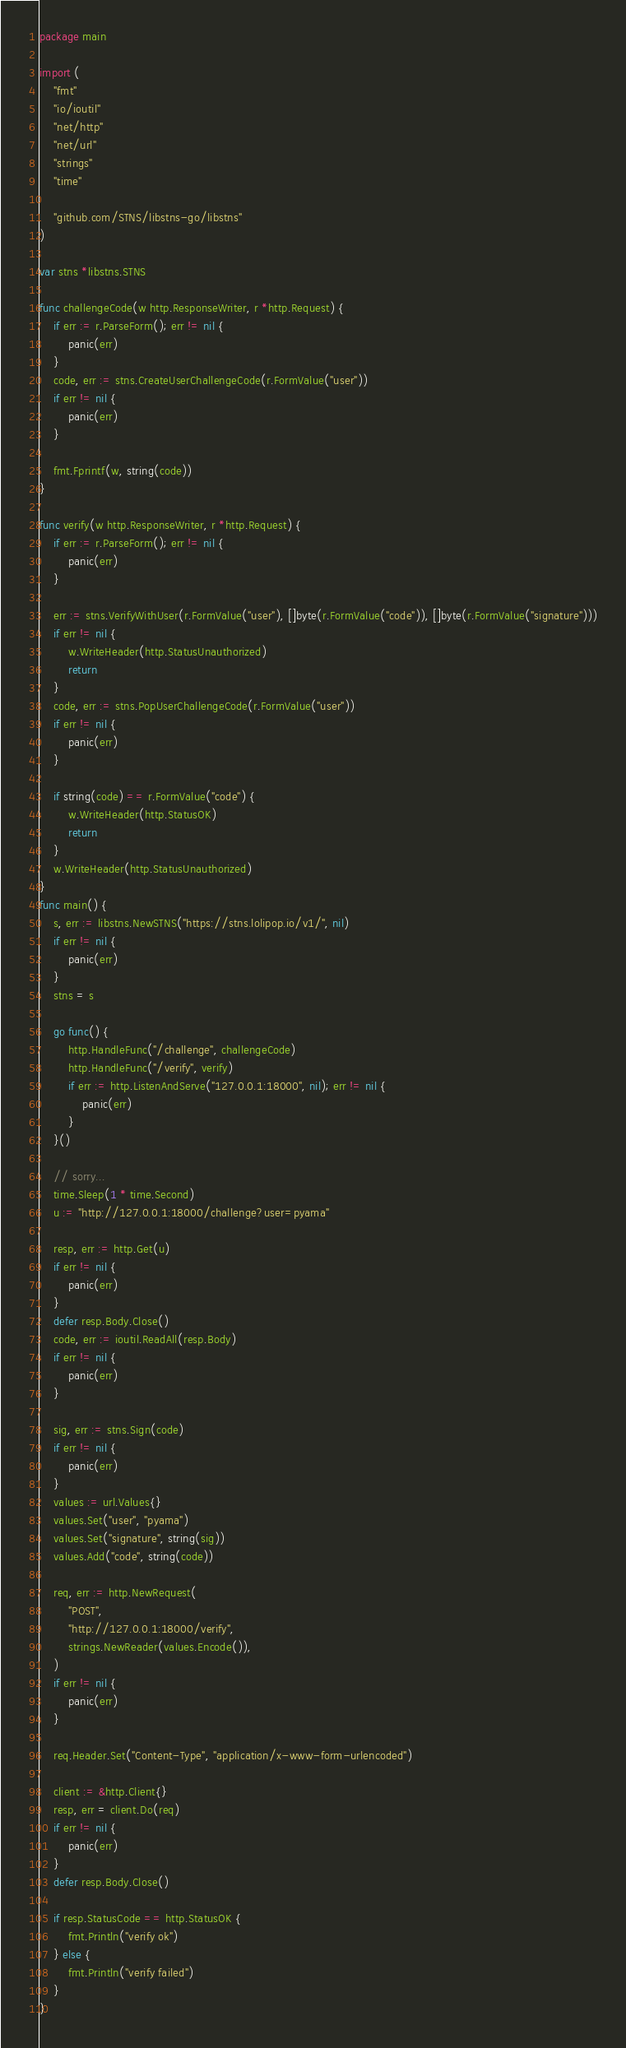Convert code to text. <code><loc_0><loc_0><loc_500><loc_500><_Go_>package main

import (
	"fmt"
	"io/ioutil"
	"net/http"
	"net/url"
	"strings"
	"time"

	"github.com/STNS/libstns-go/libstns"
)

var stns *libstns.STNS

func challengeCode(w http.ResponseWriter, r *http.Request) {
	if err := r.ParseForm(); err != nil {
		panic(err)
	}
	code, err := stns.CreateUserChallengeCode(r.FormValue("user"))
	if err != nil {
		panic(err)
	}

	fmt.Fprintf(w, string(code))
}

func verify(w http.ResponseWriter, r *http.Request) {
	if err := r.ParseForm(); err != nil {
		panic(err)
	}

	err := stns.VerifyWithUser(r.FormValue("user"), []byte(r.FormValue("code")), []byte(r.FormValue("signature")))
	if err != nil {
		w.WriteHeader(http.StatusUnauthorized)
		return
	}
	code, err := stns.PopUserChallengeCode(r.FormValue("user"))
	if err != nil {
		panic(err)
	}

	if string(code) == r.FormValue("code") {
		w.WriteHeader(http.StatusOK)
		return
	}
	w.WriteHeader(http.StatusUnauthorized)
}
func main() {
	s, err := libstns.NewSTNS("https://stns.lolipop.io/v1/", nil)
	if err != nil {
		panic(err)
	}
	stns = s

	go func() {
		http.HandleFunc("/challenge", challengeCode)
		http.HandleFunc("/verify", verify)
		if err := http.ListenAndServe("127.0.0.1:18000", nil); err != nil {
			panic(err)
		}
	}()

	// sorry...
	time.Sleep(1 * time.Second)
	u := "http://127.0.0.1:18000/challenge?user=pyama"

	resp, err := http.Get(u)
	if err != nil {
		panic(err)
	}
	defer resp.Body.Close()
	code, err := ioutil.ReadAll(resp.Body)
	if err != nil {
		panic(err)
	}

	sig, err := stns.Sign(code)
	if err != nil {
		panic(err)
	}
	values := url.Values{}
	values.Set("user", "pyama")
	values.Set("signature", string(sig))
	values.Add("code", string(code))

	req, err := http.NewRequest(
		"POST",
		"http://127.0.0.1:18000/verify",
		strings.NewReader(values.Encode()),
	)
	if err != nil {
		panic(err)
	}

	req.Header.Set("Content-Type", "application/x-www-form-urlencoded")

	client := &http.Client{}
	resp, err = client.Do(req)
	if err != nil {
		panic(err)
	}
	defer resp.Body.Close()

	if resp.StatusCode == http.StatusOK {
		fmt.Println("verify ok")
	} else {
		fmt.Println("verify failed")
	}
}
</code> 